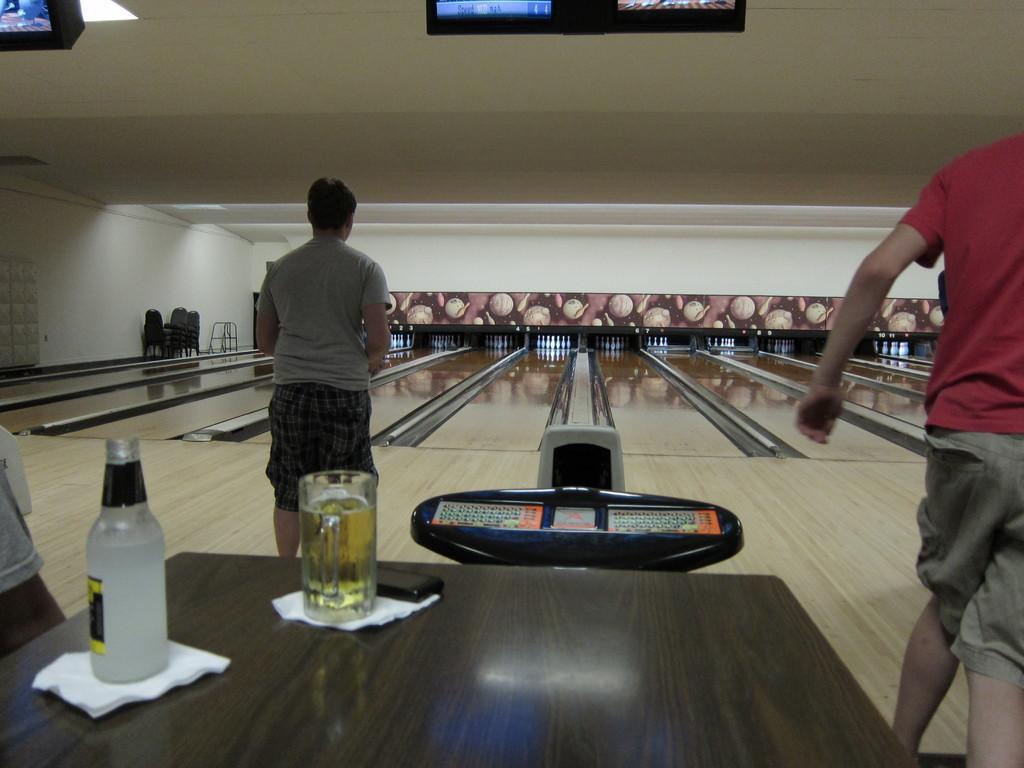Could you give a brief overview of what you see in this image? In this picture I can see tissues, mobile, a glass of wine and a bottle on the table, and there are three persons, there are chairs, bowling pins and televisions. 